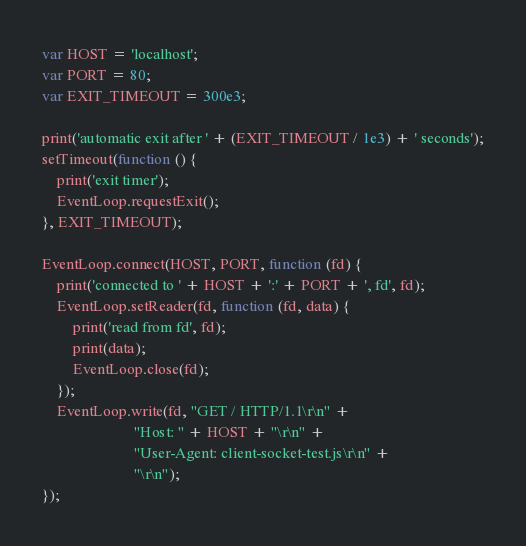<code> <loc_0><loc_0><loc_500><loc_500><_JavaScript_>
var HOST = 'localhost';
var PORT = 80;
var EXIT_TIMEOUT = 300e3;

print('automatic exit after ' + (EXIT_TIMEOUT / 1e3) + ' seconds');
setTimeout(function () {
    print('exit timer');
    EventLoop.requestExit();
}, EXIT_TIMEOUT);

EventLoop.connect(HOST, PORT, function (fd) {
    print('connected to ' + HOST + ':' + PORT + ', fd', fd);
    EventLoop.setReader(fd, function (fd, data) {
        print('read from fd', fd);
        print(data);
        EventLoop.close(fd);
    });
    EventLoop.write(fd, "GET / HTTP/1.1\r\n" +
                        "Host: " + HOST + "\r\n" +
                        "User-Agent: client-socket-test.js\r\n" +
                        "\r\n");
});

</code> 